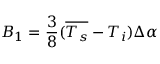<formula> <loc_0><loc_0><loc_500><loc_500>B _ { 1 } = \frac { 3 } { 8 } ( \overline { { T _ { s } } } - T _ { i } ) \Delta \alpha</formula> 